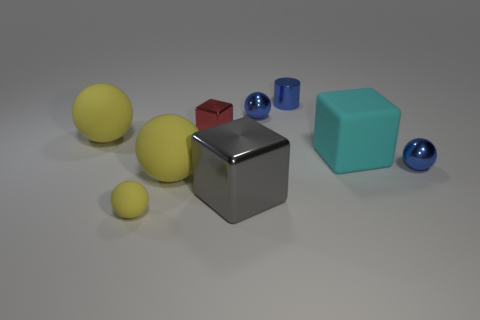Subtract all cyan cylinders. How many yellow spheres are left? 3 Subtract 2 spheres. How many spheres are left? 3 Subtract all small red cubes. How many cubes are left? 2 Subtract all blue balls. How many balls are left? 3 Subtract all spheres. How many objects are left? 4 Subtract all purple balls. Subtract all purple blocks. How many balls are left? 5 Subtract all cyan objects. Subtract all big metallic blocks. How many objects are left? 7 Add 2 tiny red metallic objects. How many tiny red metallic objects are left? 3 Add 2 tiny gray matte cylinders. How many tiny gray matte cylinders exist? 2 Subtract 1 yellow balls. How many objects are left? 8 